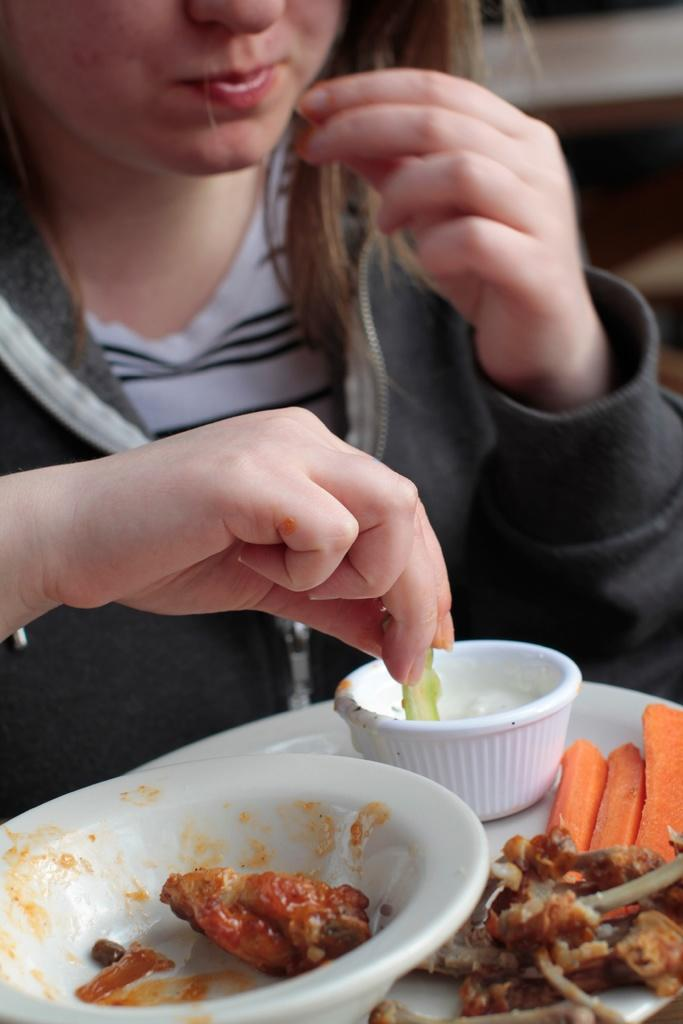Who is the main subject in the image? There is a girl in the image. What is the girl doing in the image? The girl is eating food. How is the girl eating the food? The girl is using her hands to eat the food. What type of leaf is the girl using to eat the food? There is no leaf present in the image; the girl is using her hands to eat the food. Can you tell me how the girl's father is involved in the image? There is no mention of a father or any other person in the image; it only features the girl. 